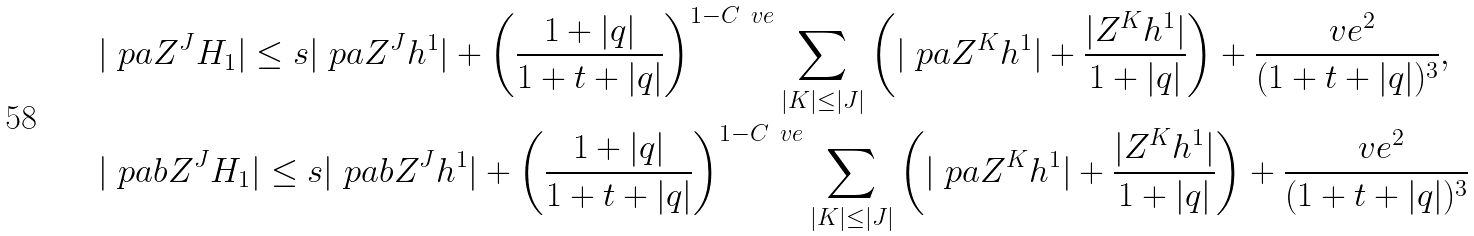Convert formula to latex. <formula><loc_0><loc_0><loc_500><loc_500>& | \ p a Z ^ { J } H _ { 1 } | \leq s | \ p a Z ^ { J } h ^ { 1 } | + \left ( \frac { 1 + | q | } { 1 + t + | q | } \right ) ^ { 1 - C \ v e } \sum _ { | K | \leq | J | } \left ( | \ p a Z ^ { K } h ^ { 1 } | + \frac { | Z ^ { K } h ^ { 1 } | } { 1 + | q | } \right ) + \frac { \ v e ^ { 2 } } { ( 1 + t + | q | ) ^ { 3 } } , \\ & | \ p a b Z ^ { J } H _ { 1 } | \leq s | \ p a b Z ^ { J } h ^ { 1 } | + \left ( \frac { 1 + | q | } { 1 + t + | q | } \right ) ^ { 1 - C \ v e } \sum _ { | K | \leq | J | } \left ( | \ p a Z ^ { K } h ^ { 1 } | + \frac { | Z ^ { K } h ^ { 1 } | } { 1 + | q | } \right ) + \frac { \ v e ^ { 2 } } { ( 1 + t + | q | ) ^ { 3 } }</formula> 